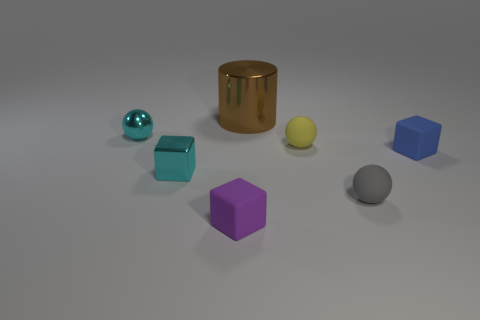Subtract all cyan spheres. How many spheres are left? 2 Subtract all cyan blocks. How many blocks are left? 2 Add 3 tiny shiny cubes. How many tiny shiny cubes are left? 4 Add 5 tiny gray spheres. How many tiny gray spheres exist? 6 Add 3 blue shiny cylinders. How many objects exist? 10 Subtract 1 cyan spheres. How many objects are left? 6 Subtract all blocks. How many objects are left? 4 Subtract 1 balls. How many balls are left? 2 Subtract all gray blocks. Subtract all brown balls. How many blocks are left? 3 Subtract all yellow cubes. How many yellow balls are left? 1 